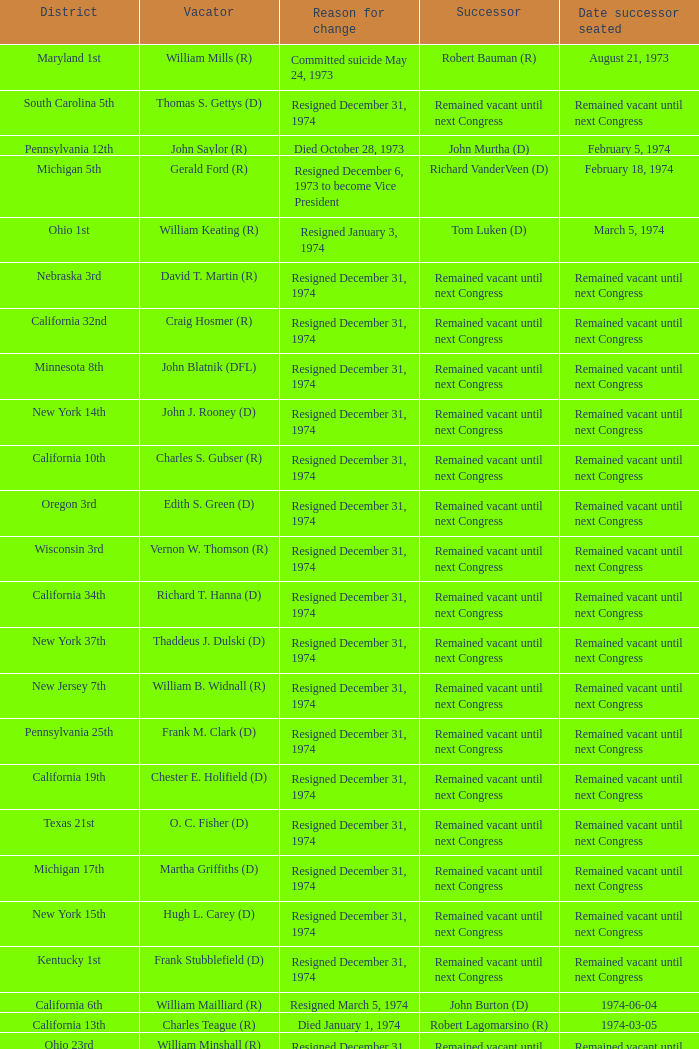Who was the vacator when the date successor seated was august 21, 1973? William Mills (R). 